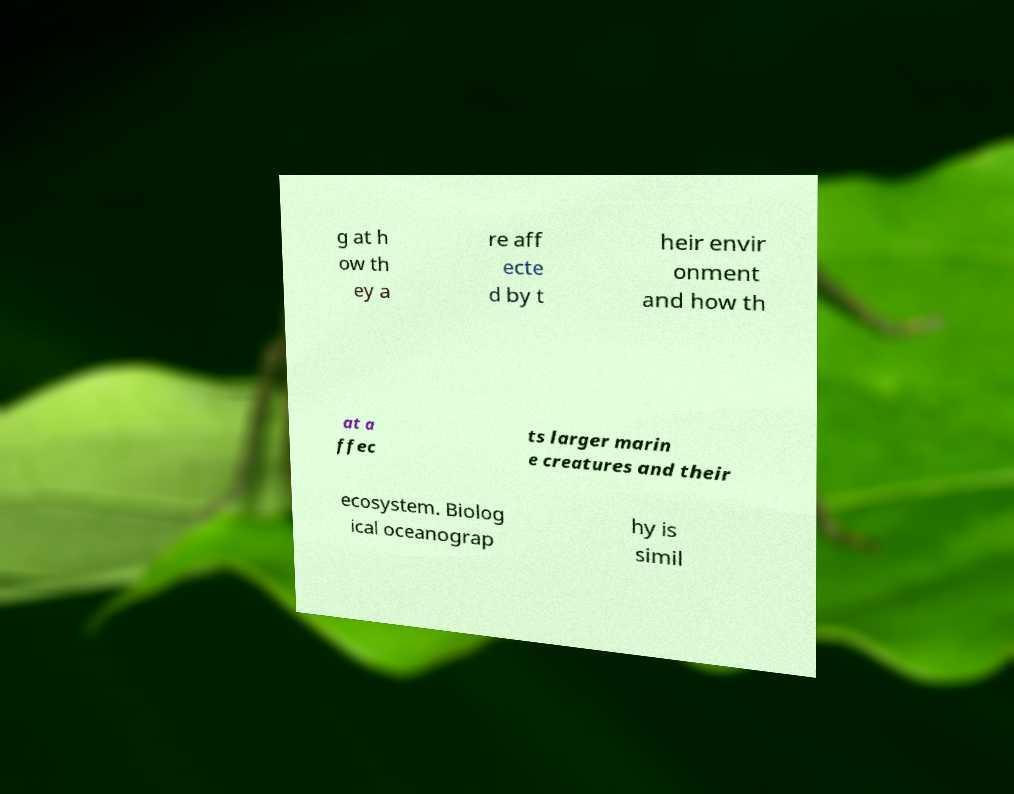There's text embedded in this image that I need extracted. Can you transcribe it verbatim? g at h ow th ey a re aff ecte d by t heir envir onment and how th at a ffec ts larger marin e creatures and their ecosystem. Biolog ical oceanograp hy is simil 